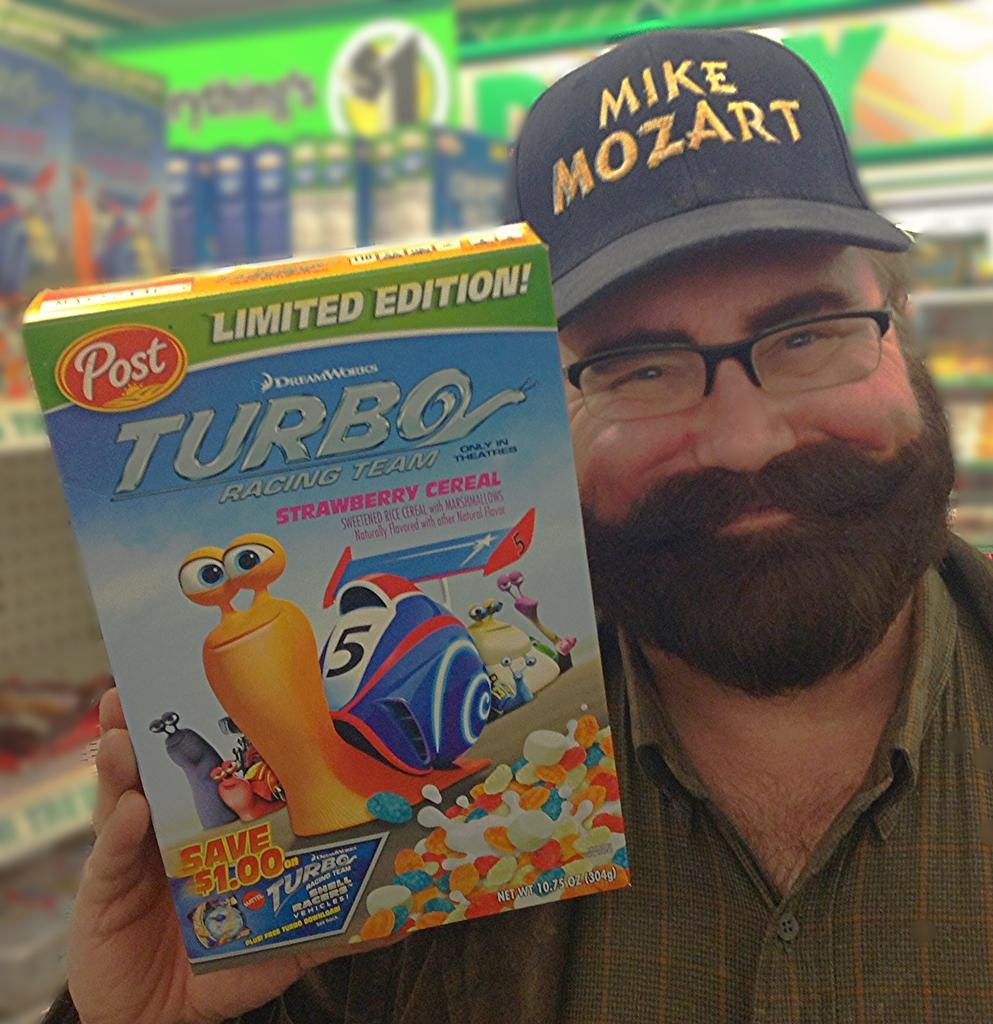What is the person in the image holding? The person is holding a box in the image. What is inside the box that the person is holding? The box contains pictures and text. What can be seen in the background of the image? There are objects placed in racks and a board with text in the background. How many quarters can be seen in the image? There are no quarters visible in the image. Is there a goose present in the image? No, there is no goose present in the image. 